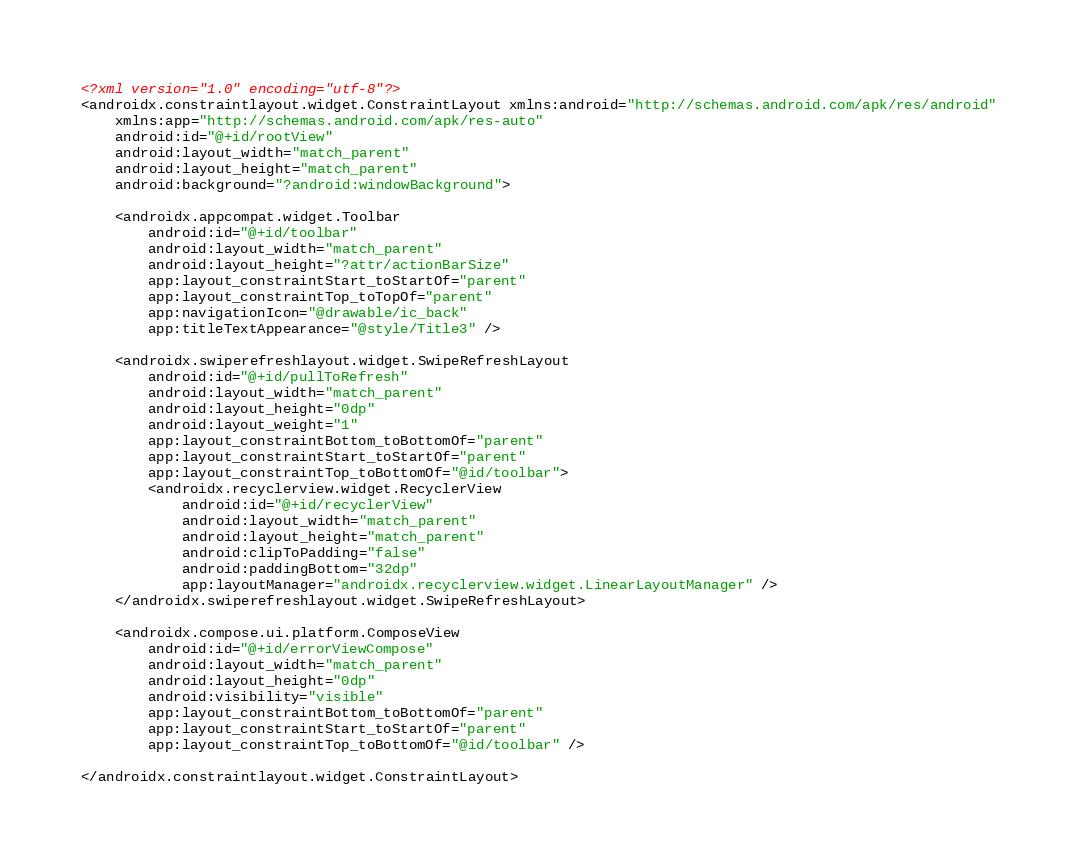Convert code to text. <code><loc_0><loc_0><loc_500><loc_500><_XML_><?xml version="1.0" encoding="utf-8"?>
<androidx.constraintlayout.widget.ConstraintLayout xmlns:android="http://schemas.android.com/apk/res/android"
    xmlns:app="http://schemas.android.com/apk/res-auto"
    android:id="@+id/rootView"
    android:layout_width="match_parent"
    android:layout_height="match_parent"
    android:background="?android:windowBackground">

    <androidx.appcompat.widget.Toolbar
        android:id="@+id/toolbar"
        android:layout_width="match_parent"
        android:layout_height="?attr/actionBarSize"
        app:layout_constraintStart_toStartOf="parent"
        app:layout_constraintTop_toTopOf="parent"
        app:navigationIcon="@drawable/ic_back"
        app:titleTextAppearance="@style/Title3" />

    <androidx.swiperefreshlayout.widget.SwipeRefreshLayout
        android:id="@+id/pullToRefresh"
        android:layout_width="match_parent"
        android:layout_height="0dp"
        android:layout_weight="1"
        app:layout_constraintBottom_toBottomOf="parent"
        app:layout_constraintStart_toStartOf="parent"
        app:layout_constraintTop_toBottomOf="@id/toolbar">
        <androidx.recyclerview.widget.RecyclerView
            android:id="@+id/recyclerView"
            android:layout_width="match_parent"
            android:layout_height="match_parent"
            android:clipToPadding="false"
            android:paddingBottom="32dp"
            app:layoutManager="androidx.recyclerview.widget.LinearLayoutManager" />
    </androidx.swiperefreshlayout.widget.SwipeRefreshLayout>

    <androidx.compose.ui.platform.ComposeView
        android:id="@+id/errorViewCompose"
        android:layout_width="match_parent"
        android:layout_height="0dp"
        android:visibility="visible"
        app:layout_constraintBottom_toBottomOf="parent"
        app:layout_constraintStart_toStartOf="parent"
        app:layout_constraintTop_toBottomOf="@id/toolbar" />

</androidx.constraintlayout.widget.ConstraintLayout>
</code> 